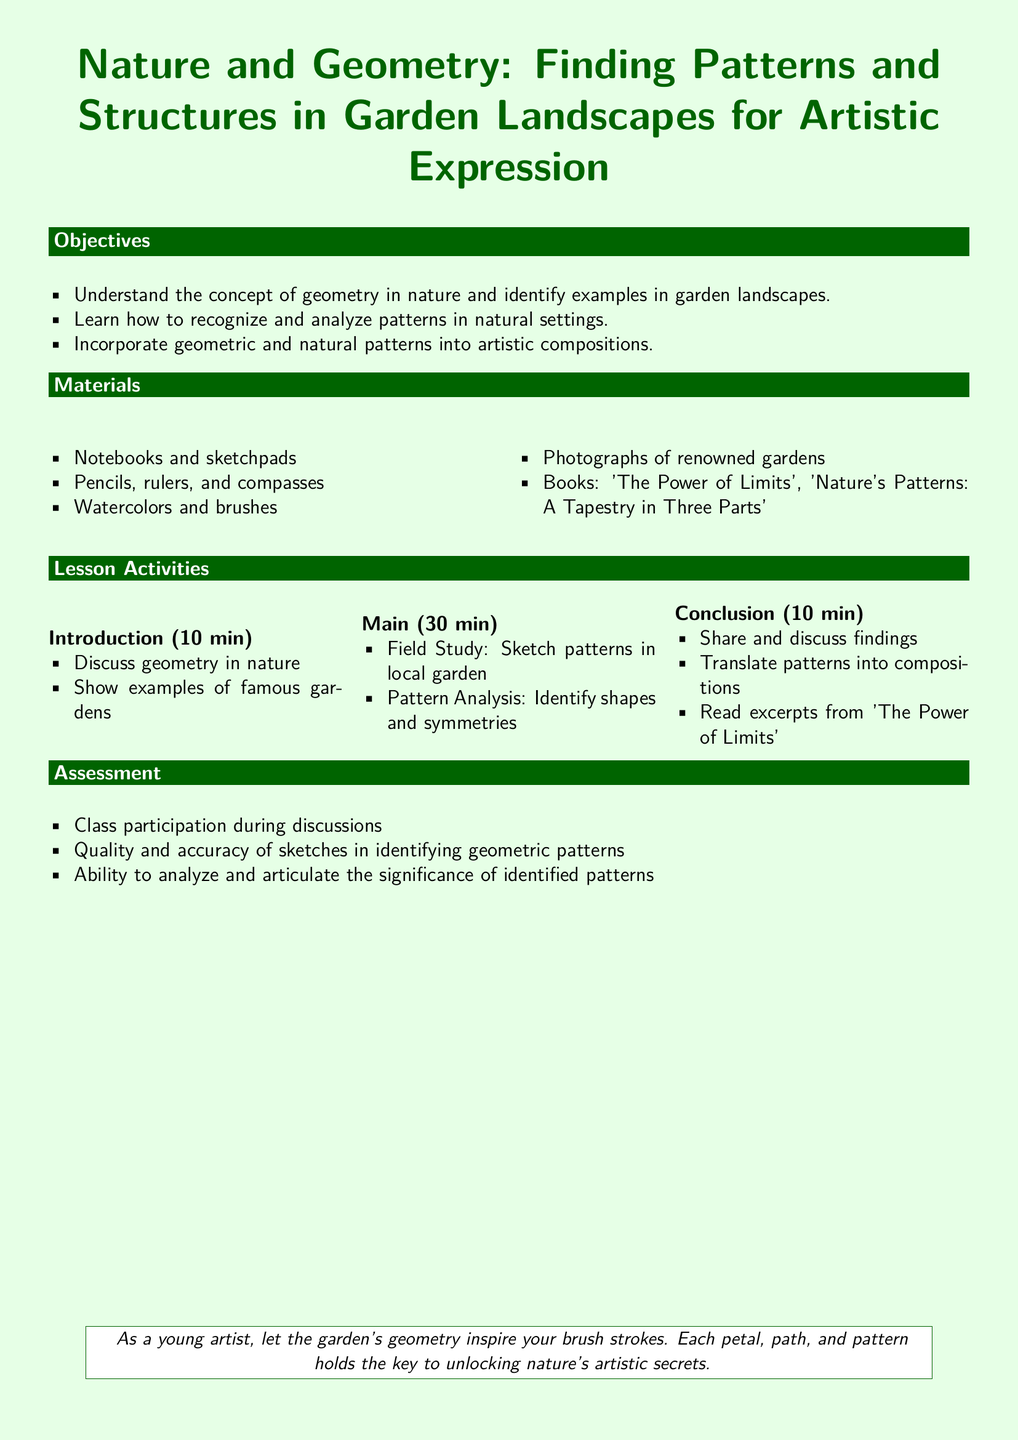what is the title of the lesson plan? The title of the lesson plan is the main heading at the top of the document.
Answer: Nature and Geometry: Finding Patterns and Structures in Garden Landscapes for Artistic Expression how long is the main activity section in minutes? The main activity section is specified in the lesson activities part of the document, which states it lasts for a certain duration.
Answer: 30 min what materials are needed for the lesson? The materials are listed under the Materials section of the document, detailing various art supplies and books.
Answer: Notebooks and sketchpads, Pencils, rulers, and compasses, Watercolors and brushes, Photographs of renowned gardens, Books: 'The Power of Limits', 'Nature's Patterns: A Tapestry in Three Parts' what is one objective of the lesson? The objectives are outlined at the beginning of the document, providing specific learnable skills or understanding gained.
Answer: Understand the concept of geometry in nature and identify examples in garden landscapes how will participation be assessed? The assessment criteria focus on different aspects of the lesson, including participation during discussions, which can be inferred from the assessment section.
Answer: Class participation during discussions what type of study is conducted in the main activity? This is noted in the main activity section, describing a hands-on approach to learning.
Answer: Field Study what is the duration of the introduction section? The duration of the introduction section is specified in the lesson activities part of the document, detailing how long introductory discussions will take.
Answer: 10 min what is suggested to inspire artistic compositions? The final notes in the document encourage a specific mindset for creating art from observing nature.
Answer: The garden's geometry what is the conclusion activity? The conclusion activity includes sharing findings, as mentioned in the conclusion section of the document.
Answer: Share and discuss findings what is one book mentioned in the materials? The book titles are included in the materials section of the document, specifying learning resources for the lesson.
Answer: 'The Power of Limits' 